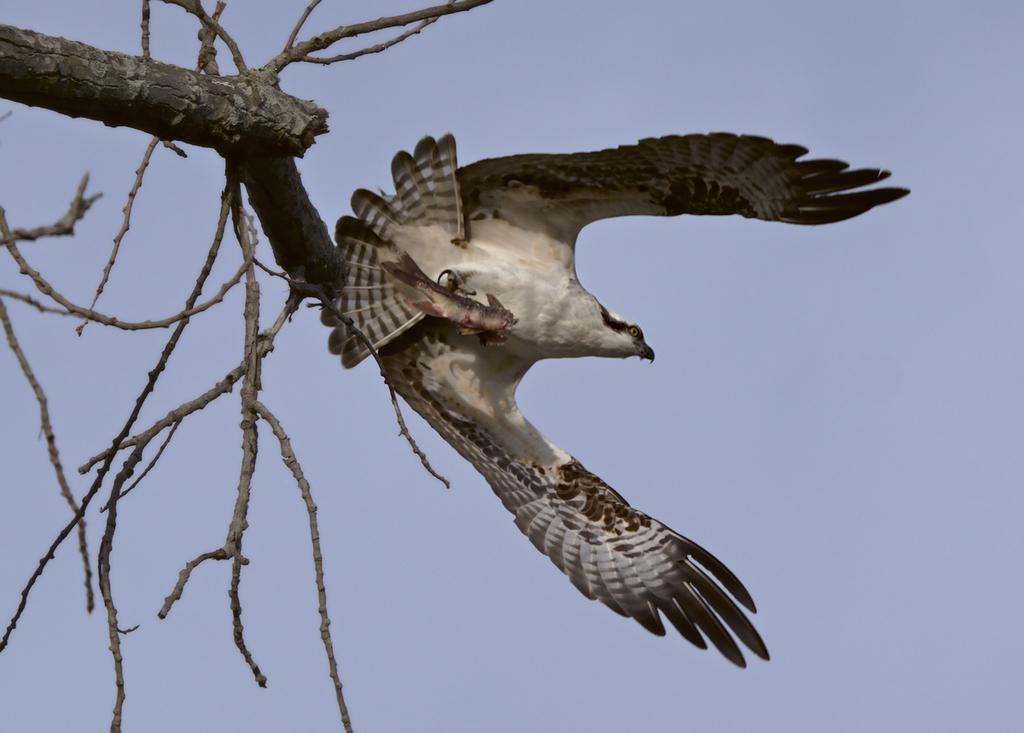What type of animal can be seen in the image? There is a bird in the image. What is the condition of the tree in the image? There is a dried tree in the image. What part of the natural environment is visible in the image? The sky is visible in the image. Where is the girl playing in the yard in the image? There is no girl or yard present in the image; it features a bird and a dried tree. 